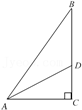Narrate what you see in the visual. The diagram displays a right triangle ABC, with angle C forming a right angle. The point D is where the line AD intersects the line BC. Point E is the intersection of the line DE, which is perpendicular to AB. 